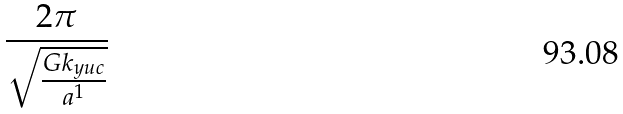Convert formula to latex. <formula><loc_0><loc_0><loc_500><loc_500>\frac { 2 \pi } { \sqrt { \frac { G k _ { y u c } } { a ^ { 1 } } } }</formula> 